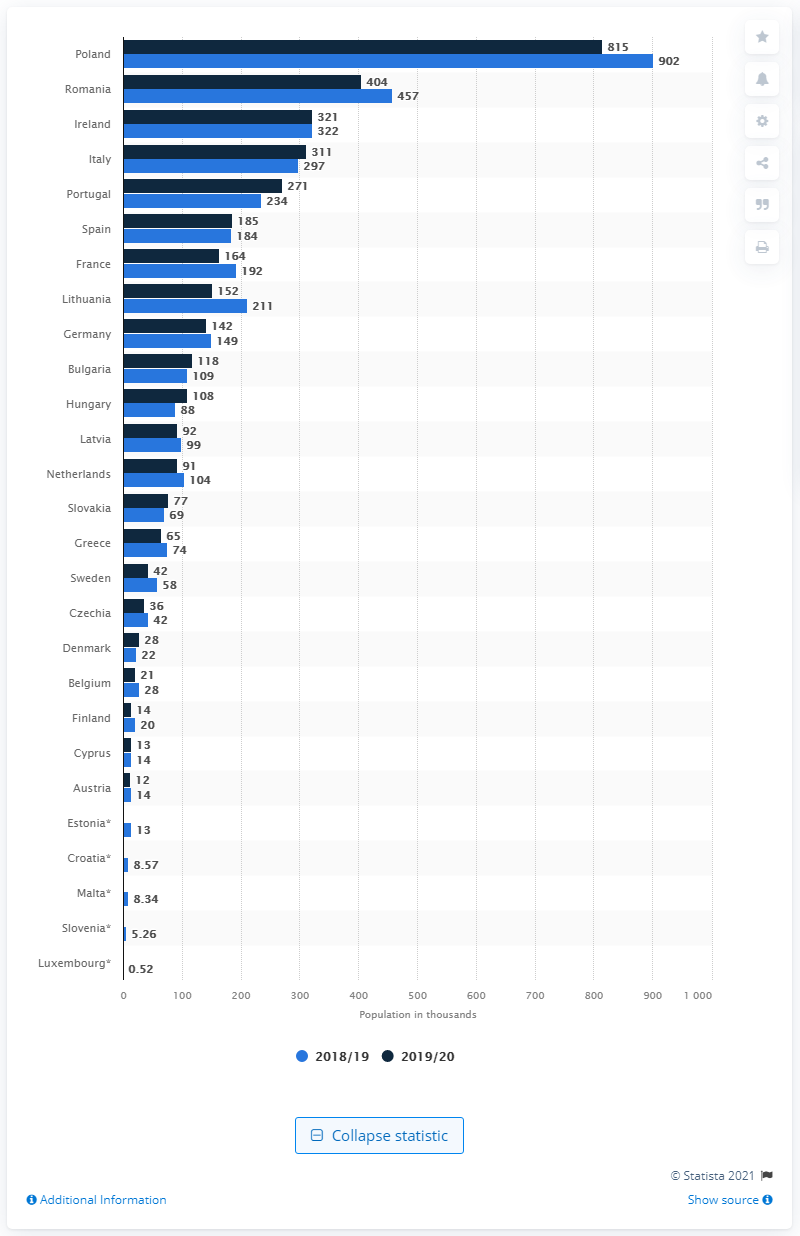Identify some key points in this picture. According to statistics, Spain was the most favored destination among British nationals living in the European Union. 